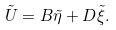<formula> <loc_0><loc_0><loc_500><loc_500>\tilde { U } = B \tilde { \eta } + D \tilde { \xi } .</formula> 